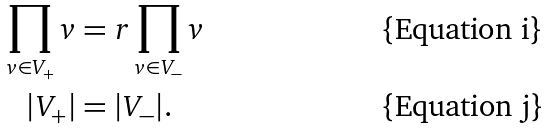<formula> <loc_0><loc_0><loc_500><loc_500>\prod _ { v \in V _ { + } } v & = r \prod _ { v \in V _ { - } } v \\ | V _ { + } | & = | V _ { - } | .</formula> 